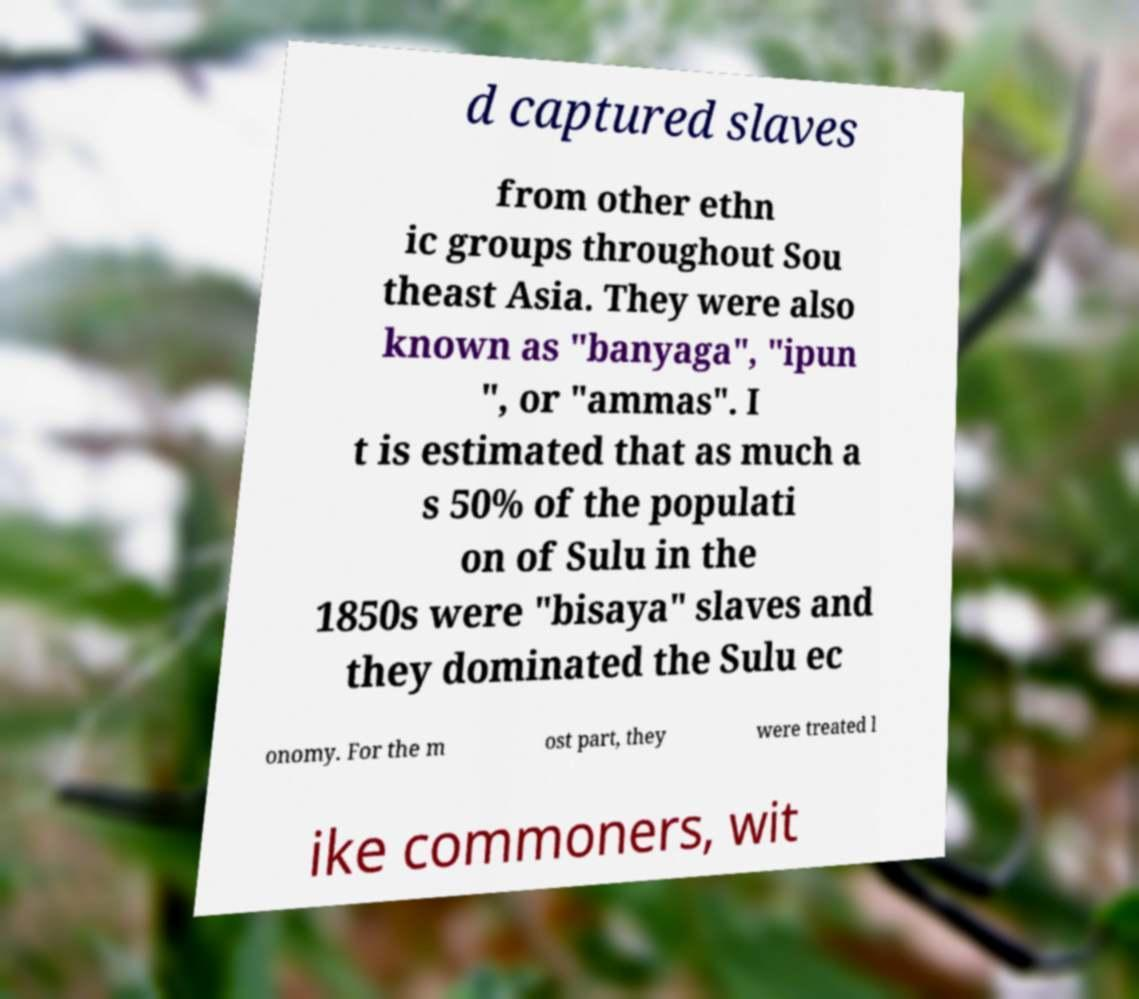For documentation purposes, I need the text within this image transcribed. Could you provide that? d captured slaves from other ethn ic groups throughout Sou theast Asia. They were also known as "banyaga", "ipun ", or "ammas". I t is estimated that as much a s 50% of the populati on of Sulu in the 1850s were "bisaya" slaves and they dominated the Sulu ec onomy. For the m ost part, they were treated l ike commoners, wit 